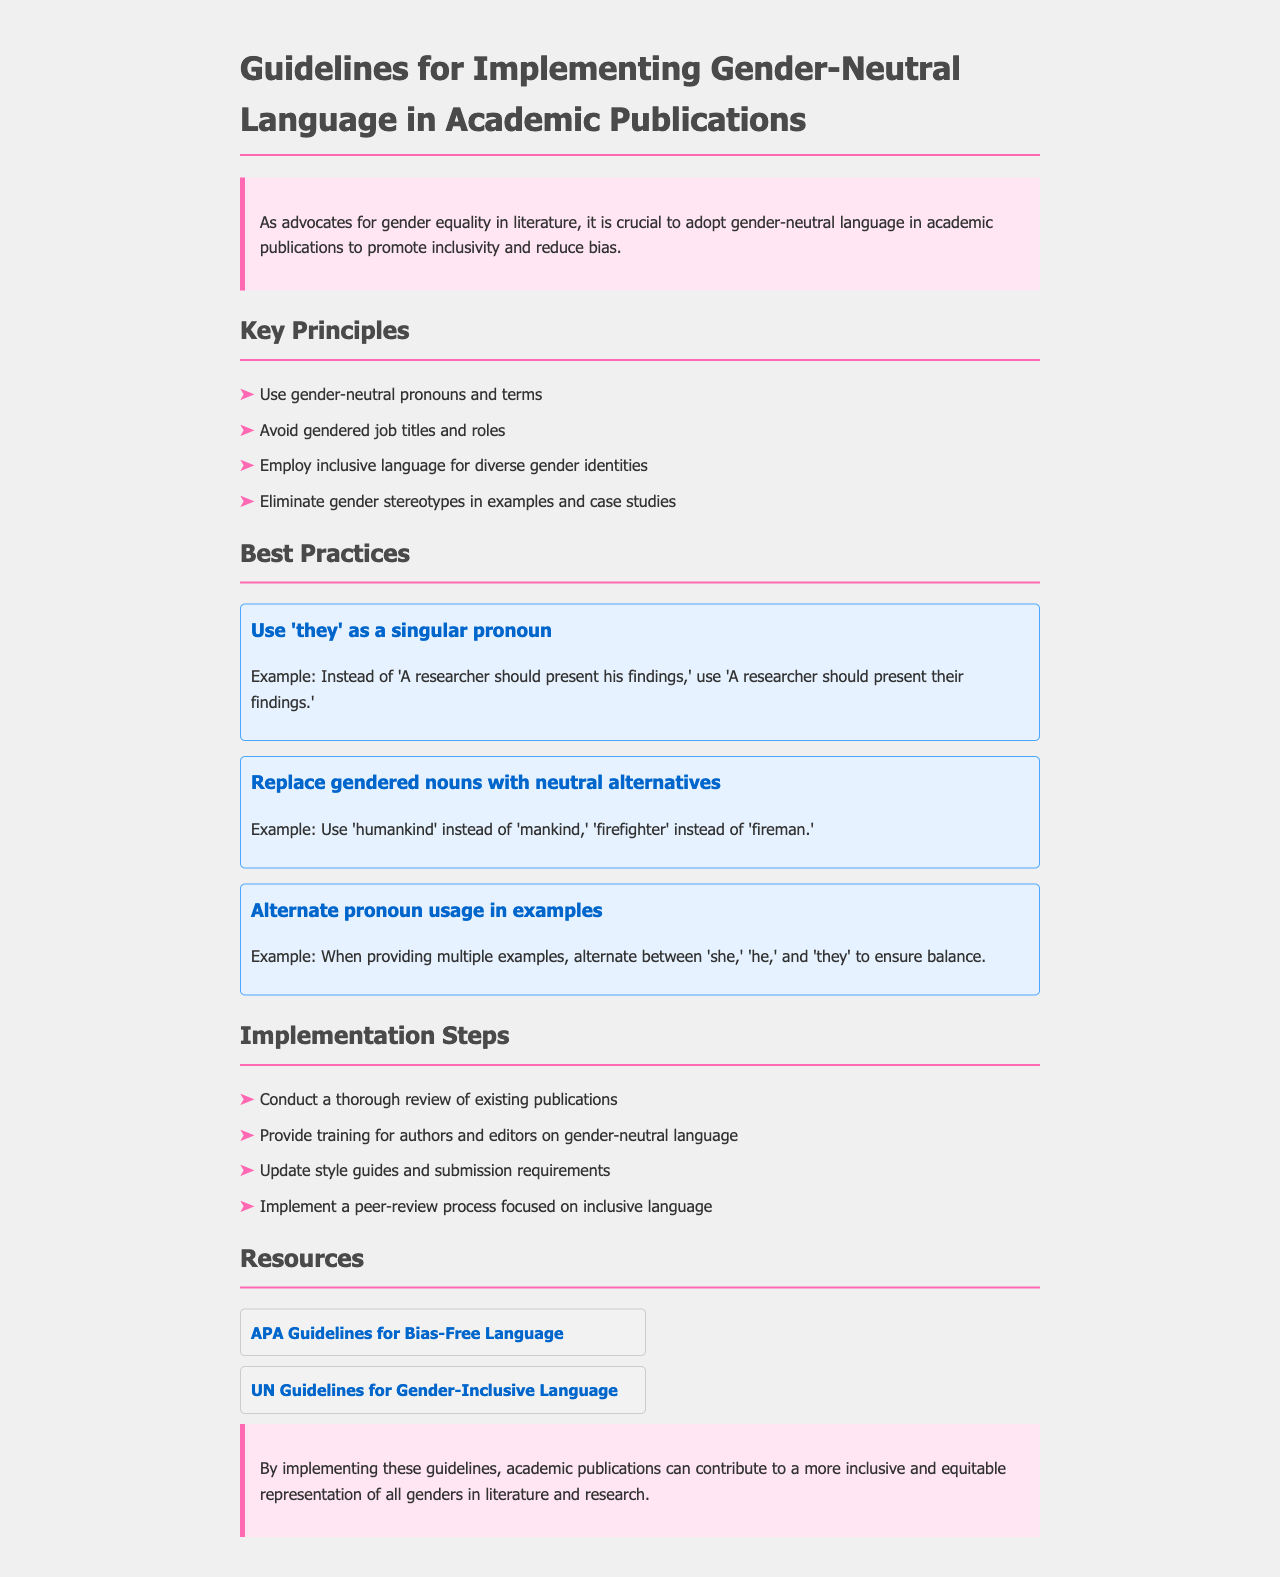What is the main goal of the guidelines? The main goal is to promote inclusivity and reduce bias in academic publications.
Answer: Promote inclusivity How many key principles are listed in the document? The document lists four key principles under key principles.
Answer: Four What singular pronoun is suggested for gender neutrality? The document suggests using 'they' as a singular pronoun.
Answer: They Which job title should be replaced with a gender-neutral term? The term 'fireman' should be replaced with 'firefighter.'
Answer: Firefighter What should be conducted for existing publications according to the implementation steps? A thorough review of existing publications should be conducted.
Answer: Thorough review Which organization provides guidelines for bias-free language? The APA provides guidelines for bias-free language.
Answer: APA What is one best practice mentioned for pronoun usage? Alternating between 'she,' 'he,' and 'they' in examples is mentioned.
Answer: Alternate pronoun usage What color is used for the heading in best practices? The header color for best practices is blue.
Answer: Blue What is the conclusion's emphasis regarding the guidelines? The conclusion emphasizes contributing to a more inclusive and equitable representation.
Answer: Inclusive representation 